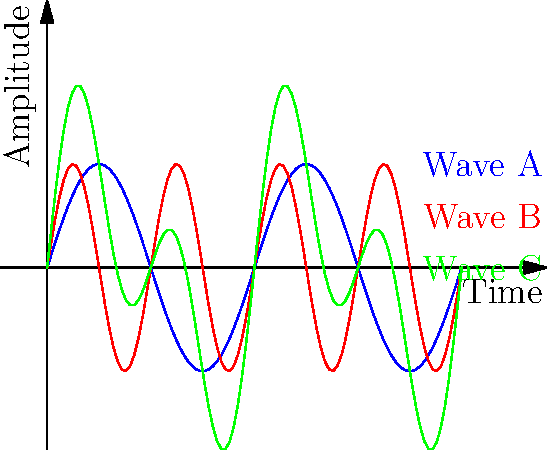Examine the sound wave patterns shown in the image. Wave C is a combination of two other waves. Which waves, when harmonized, produce Wave C? To solve this problem, we need to analyze the characteristics of each wave and understand the concept of wave superposition:

1. Wave A (blue) has a lower frequency and larger wavelength.
2. Wave B (red) has a higher frequency and smaller wavelength.
3. Wave C (green) shows a more complex pattern that seems to combine elements of both A and B.

In harmonization, when two waves are combined, their amplitudes are added at each point in time. This process is called superposition. The resulting wave (Wave C in this case) will have:

- Peaks that align with the peaks of both original waves
- Troughs that align with the troughs of both original waves
- More complex patterns where one wave has a peak and the other has a trough

Looking at Wave C, we can see that it has:
- The overall shape similar to Wave A (the lower frequency wave)
- Additional oscillations within that shape, which come from Wave B (the higher frequency wave)

This pattern is characteristic of a fundamental tone (Wave A) combined with its first harmonic or overtone (Wave B), which is a common occurrence in vocal harmonies.

Therefore, Wave C is the result of combining Wave A and Wave B.
Answer: Waves A and B 